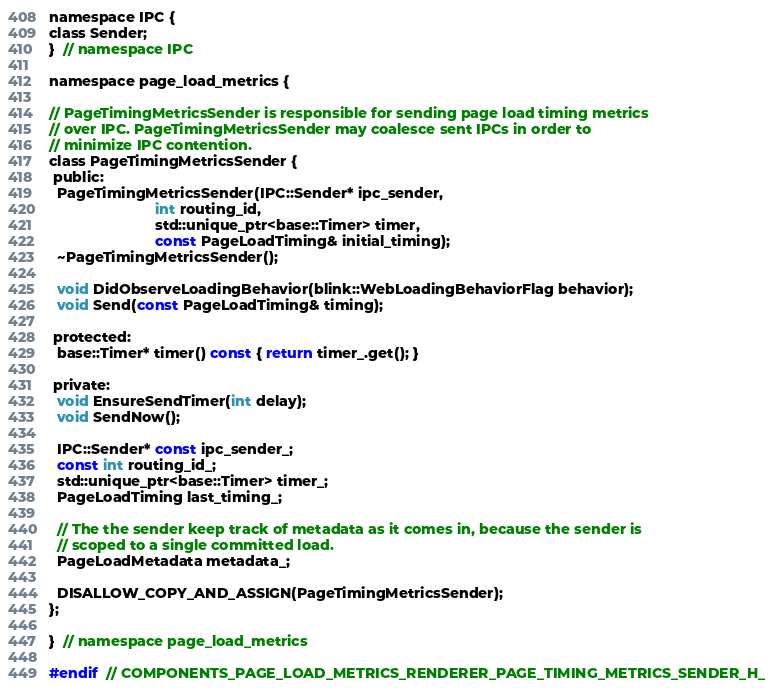<code> <loc_0><loc_0><loc_500><loc_500><_C_>
namespace IPC {
class Sender;
}  // namespace IPC

namespace page_load_metrics {

// PageTimingMetricsSender is responsible for sending page load timing metrics
// over IPC. PageTimingMetricsSender may coalesce sent IPCs in order to
// minimize IPC contention.
class PageTimingMetricsSender {
 public:
  PageTimingMetricsSender(IPC::Sender* ipc_sender,
                          int routing_id,
                          std::unique_ptr<base::Timer> timer,
                          const PageLoadTiming& initial_timing);
  ~PageTimingMetricsSender();

  void DidObserveLoadingBehavior(blink::WebLoadingBehaviorFlag behavior);
  void Send(const PageLoadTiming& timing);

 protected:
  base::Timer* timer() const { return timer_.get(); }

 private:
  void EnsureSendTimer(int delay);
  void SendNow();

  IPC::Sender* const ipc_sender_;
  const int routing_id_;
  std::unique_ptr<base::Timer> timer_;
  PageLoadTiming last_timing_;

  // The the sender keep track of metadata as it comes in, because the sender is
  // scoped to a single committed load.
  PageLoadMetadata metadata_;

  DISALLOW_COPY_AND_ASSIGN(PageTimingMetricsSender);
};

}  // namespace page_load_metrics

#endif  // COMPONENTS_PAGE_LOAD_METRICS_RENDERER_PAGE_TIMING_METRICS_SENDER_H_
</code> 